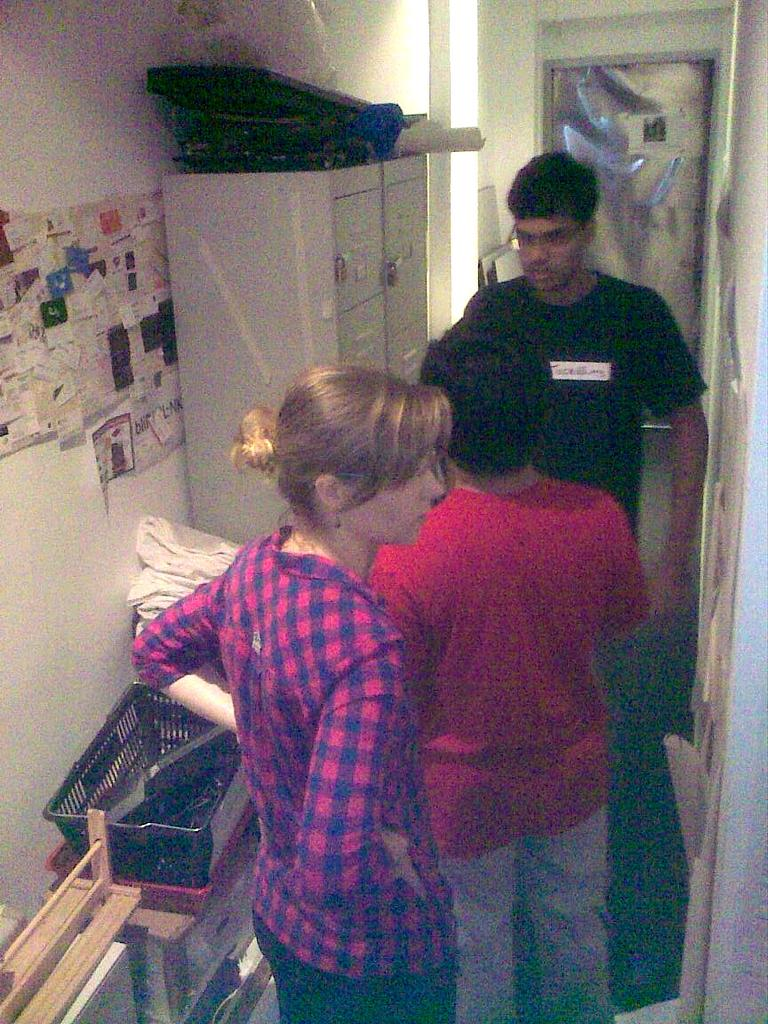What can be seen in the image regarding people? There are persons standing in the image. Where are the persons standing? The persons are standing on the floor. What is on the wall in the image? There are papers pasted on the wall. What type of furniture is present in the image? Storage containers and a cupboard are present in the image. What is placed on the cupboard? Objects are placed on the cupboard. What type of alley can be seen in the image? There is no alley present in the image. How does the afterthought affect the persons standing in the image? There is no mention of an afterthought in the image, so its effect on the persons standing cannot be determined. 